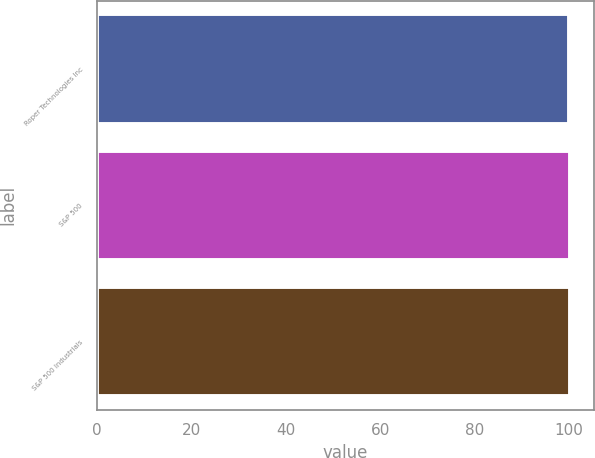<chart> <loc_0><loc_0><loc_500><loc_500><bar_chart><fcel>Roper Technologies Inc<fcel>S&P 500<fcel>S&P 500 Industrials<nl><fcel>100<fcel>100.1<fcel>100.2<nl></chart> 